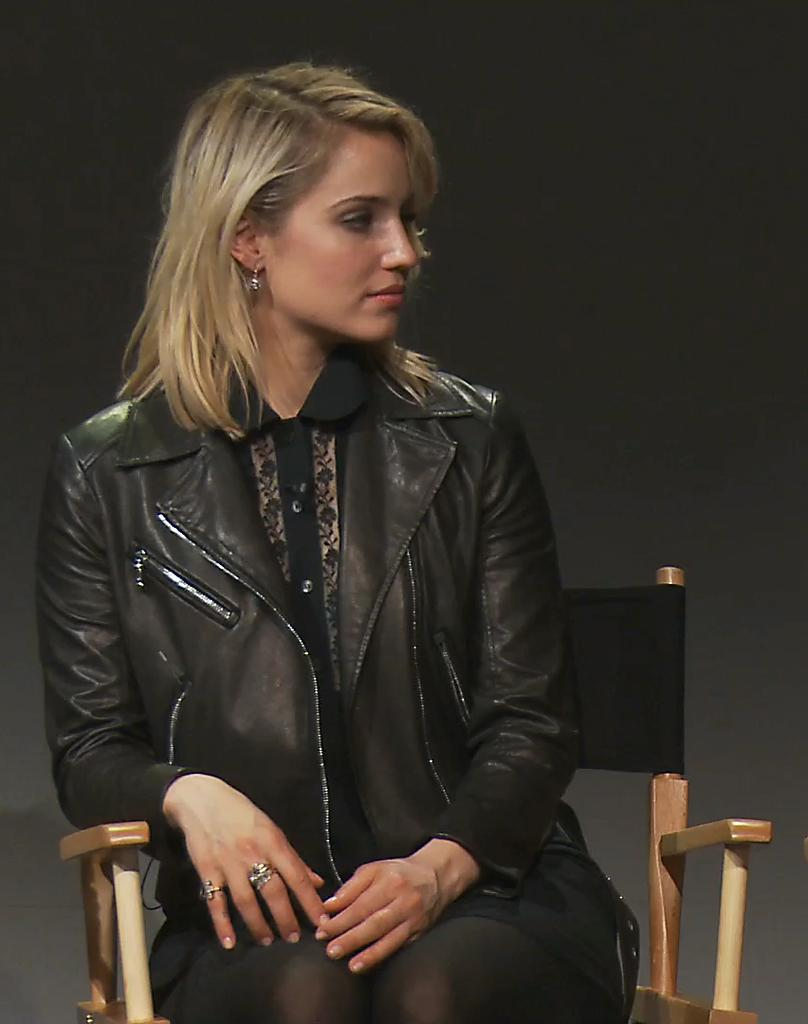Who is the main subject in the picture? There is a woman in the picture. What is the woman wearing in the image? The woman is wearing a black jacket. What is the woman doing in the image? The woman is sitting on a chair. What type of reward is the woman holding in the image? There is no reward visible in the image; the woman is simply sitting on a chair wearing a black jacket. 